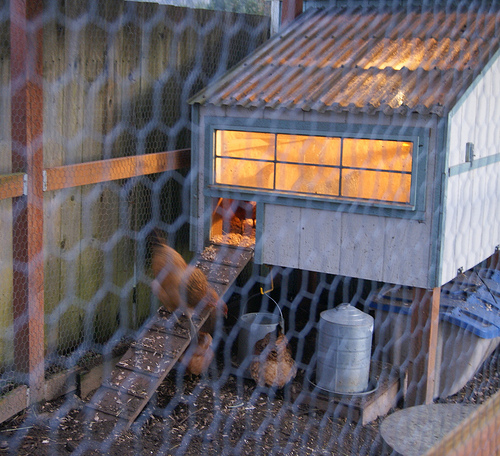<image>
Is there a chicken behind the fence? Yes. From this viewpoint, the chicken is positioned behind the fence, with the fence partially or fully occluding the chicken. Is the chicken in front of the fence? No. The chicken is not in front of the fence. The spatial positioning shows a different relationship between these objects. 